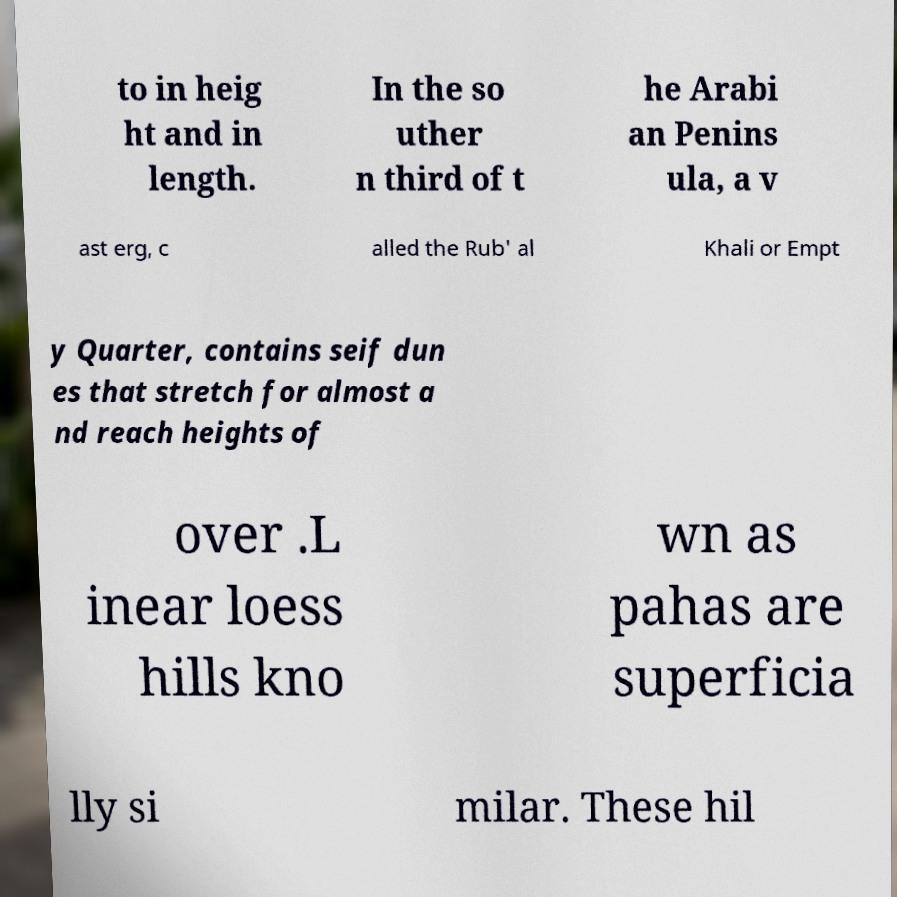Could you extract and type out the text from this image? to in heig ht and in length. In the so uther n third of t he Arabi an Penins ula, a v ast erg, c alled the Rub' al Khali or Empt y Quarter, contains seif dun es that stretch for almost a nd reach heights of over .L inear loess hills kno wn as pahas are superficia lly si milar. These hil 